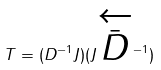Convert formula to latex. <formula><loc_0><loc_0><loc_500><loc_500>T = ( D ^ { - 1 } J ) ( J \overleftarrow { \bar { D } } ^ { - 1 } )</formula> 